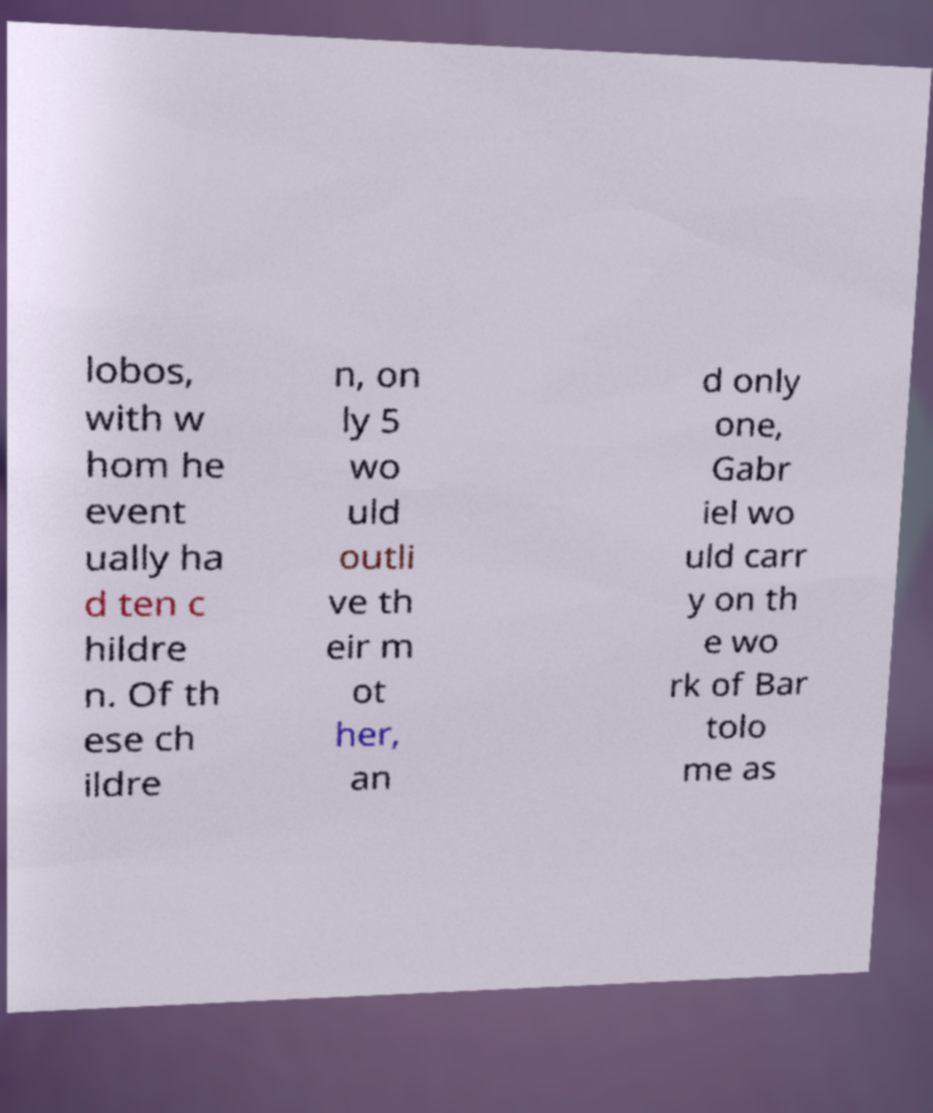Can you accurately transcribe the text from the provided image for me? lobos, with w hom he event ually ha d ten c hildre n. Of th ese ch ildre n, on ly 5 wo uld outli ve th eir m ot her, an d only one, Gabr iel wo uld carr y on th e wo rk of Bar tolo me as 